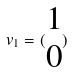<formula> <loc_0><loc_0><loc_500><loc_500>v _ { 1 } = ( \begin{matrix} 1 \\ 0 \end{matrix} )</formula> 